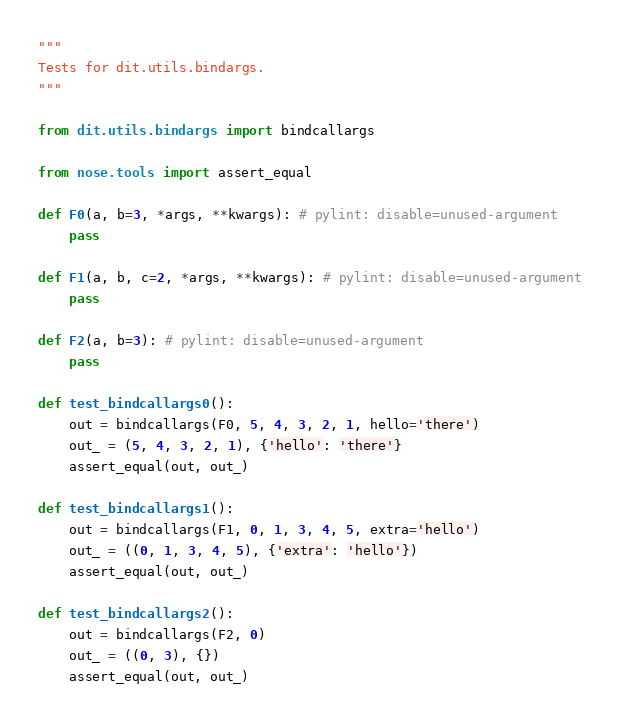<code> <loc_0><loc_0><loc_500><loc_500><_Python_>"""
Tests for dit.utils.bindargs.
"""

from dit.utils.bindargs import bindcallargs

from nose.tools import assert_equal

def F0(a, b=3, *args, **kwargs): # pylint: disable=unused-argument
    pass

def F1(a, b, c=2, *args, **kwargs): # pylint: disable=unused-argument
    pass

def F2(a, b=3): # pylint: disable=unused-argument
    pass

def test_bindcallargs0():
    out = bindcallargs(F0, 5, 4, 3, 2, 1, hello='there')
    out_ = (5, 4, 3, 2, 1), {'hello': 'there'}
    assert_equal(out, out_)

def test_bindcallargs1():
    out = bindcallargs(F1, 0, 1, 3, 4, 5, extra='hello')
    out_ = ((0, 1, 3, 4, 5), {'extra': 'hello'})
    assert_equal(out, out_)

def test_bindcallargs2():
    out = bindcallargs(F2, 0)
    out_ = ((0, 3), {})
    assert_equal(out, out_)

</code> 